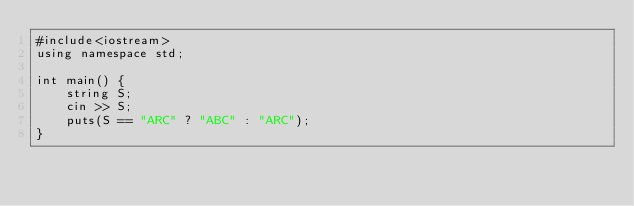<code> <loc_0><loc_0><loc_500><loc_500><_C++_>#include<iostream>
using namespace std;

int main() {
    string S;
    cin >> S;
    puts(S == "ARC" ? "ABC" : "ARC");
}</code> 